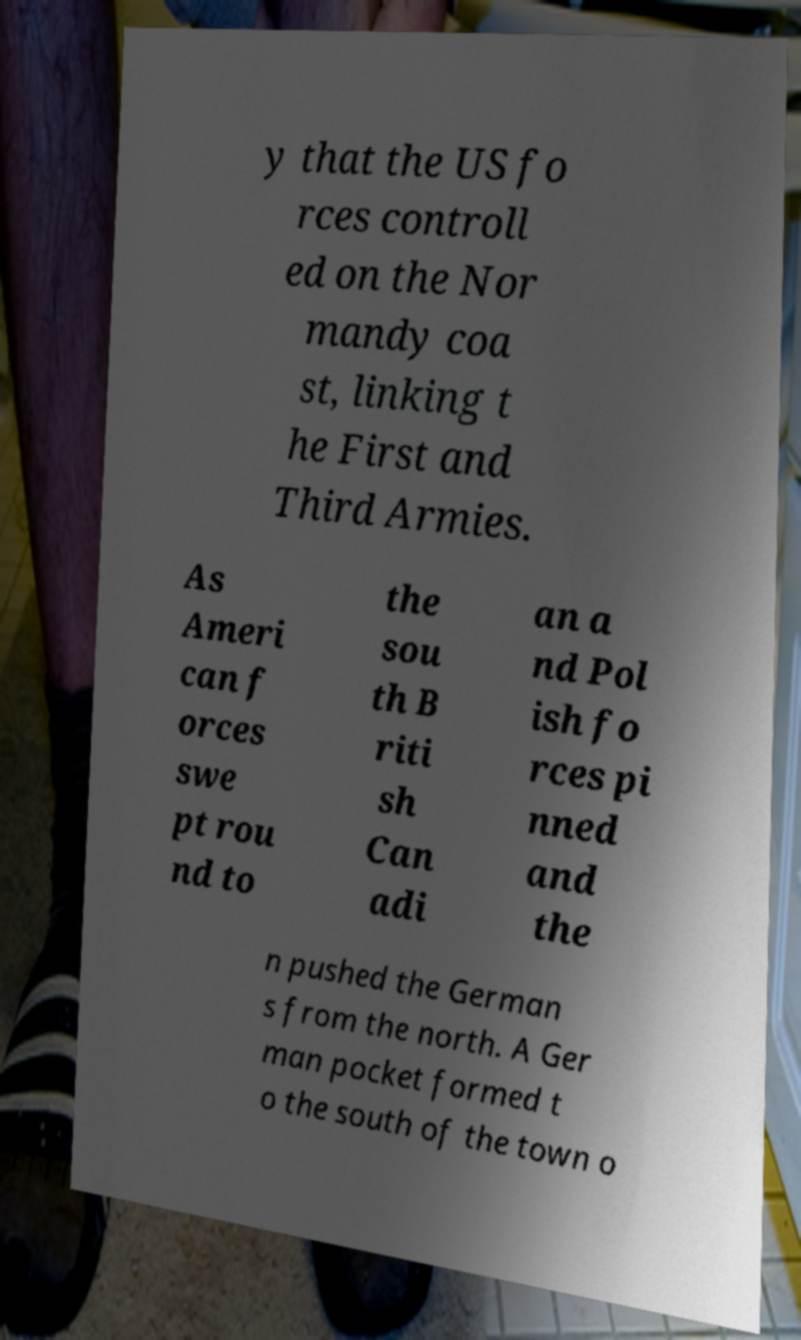What messages or text are displayed in this image? I need them in a readable, typed format. y that the US fo rces controll ed on the Nor mandy coa st, linking t he First and Third Armies. As Ameri can f orces swe pt rou nd to the sou th B riti sh Can adi an a nd Pol ish fo rces pi nned and the n pushed the German s from the north. A Ger man pocket formed t o the south of the town o 